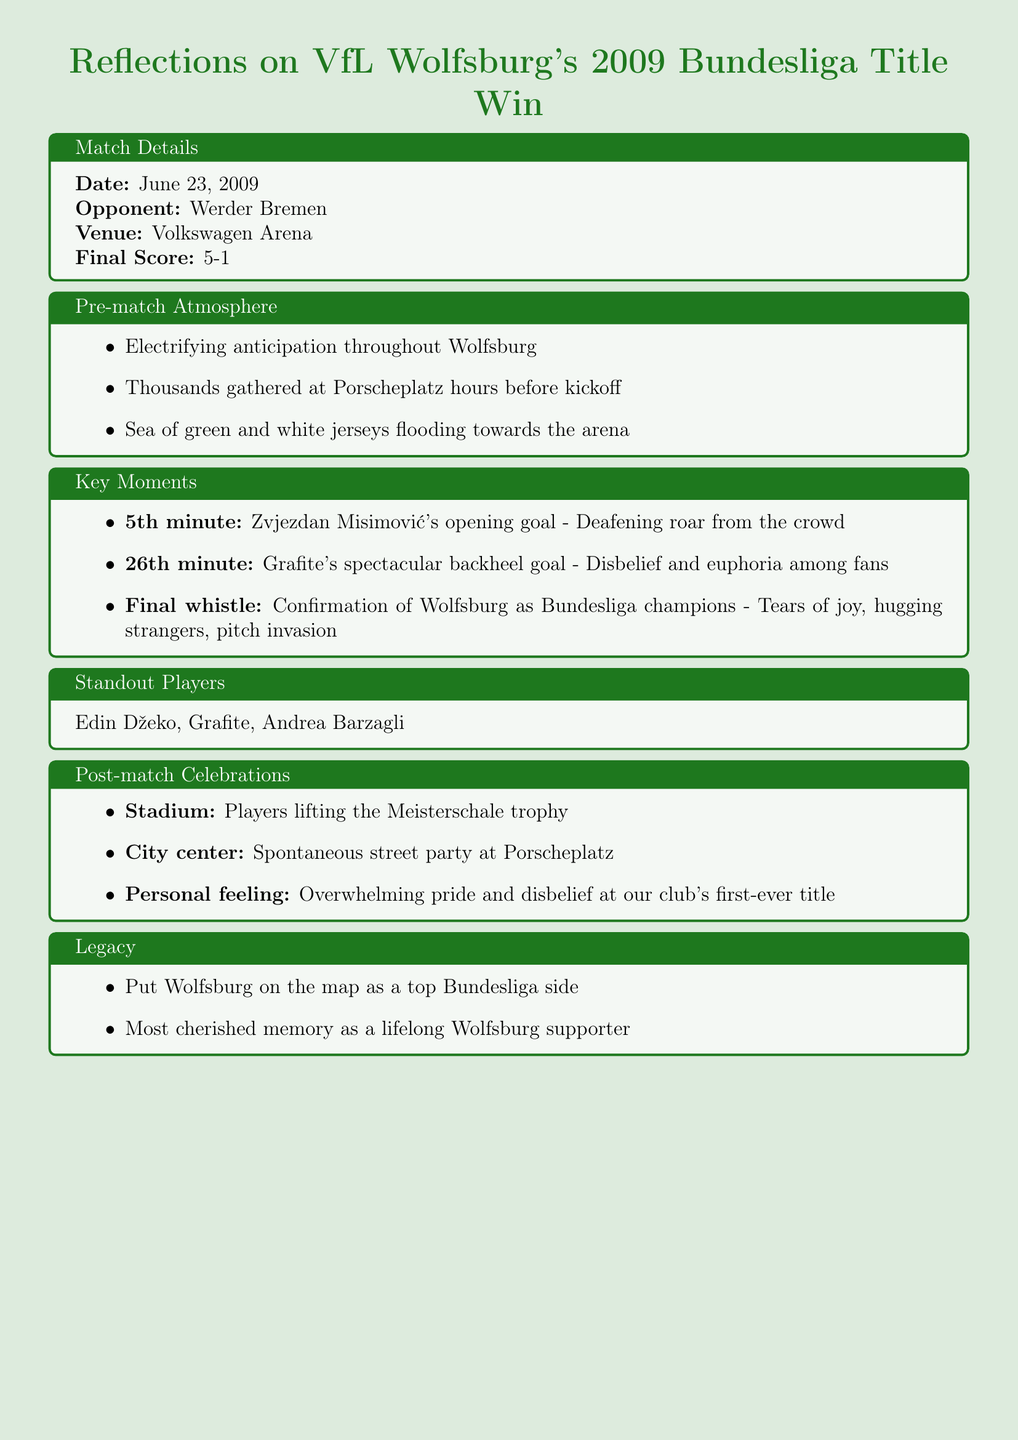What was the date of the match? The date of the match is stated in the match details section of the document.
Answer: June 23, 2009 Who was the opponent in the title-winning match? The document provides the name of the opponent in the match details section.
Answer: Werder Bremen What was the final score of the match? The final score is included in the match details and illustrates the match outcome.
Answer: 5-1 What significant event occurred in the 5th minute? The document describes a key moment in the match and specifies the event at that time.
Answer: Zvjezdan Misimović's opening goal What atmosphere was felt in Wolfsburg before the match? The pre-match atmosphere section captures the mood and feelings of the fans before the game.
Answer: Electrifying anticipation What happened after the final whistle? The document details the reaction of the fans and players at the conclusion of the match.
Answer: Tears of joy, hugging strangers, pitch invasion Which players were highlighted as standout players? The standout players section lists key contributors to the team's success in the match.
Answer: Edin Džeko, Grafite, Andrea Barzagli What trophy did the players lift after the match? The post-match celebrations mention the specific trophy lifted by the players.
Answer: Meisterschale What personal feeling did the author express regarding the title win? The document conveys the author's emotional response, reflecting on their personal experience of the event.
Answer: Overwhelming pride and disbelief 